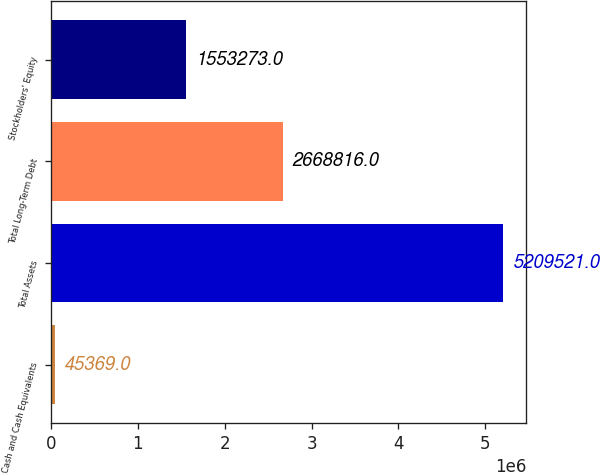<chart> <loc_0><loc_0><loc_500><loc_500><bar_chart><fcel>Cash and Cash Equivalents<fcel>Total Assets<fcel>Total Long-Term Debt<fcel>Stockholders' Equity<nl><fcel>45369<fcel>5.20952e+06<fcel>2.66882e+06<fcel>1.55327e+06<nl></chart> 